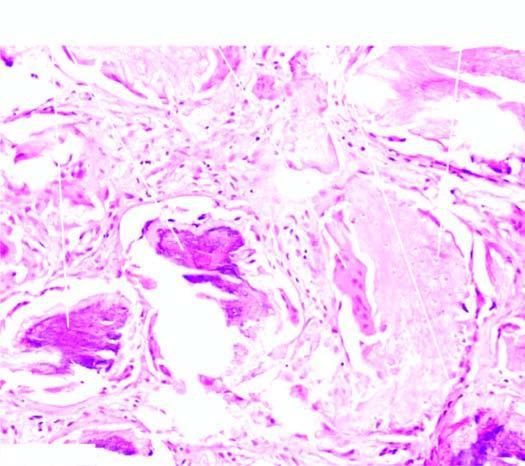how many types does the tumour show?
Answer the question using a single word or phrase. Two 